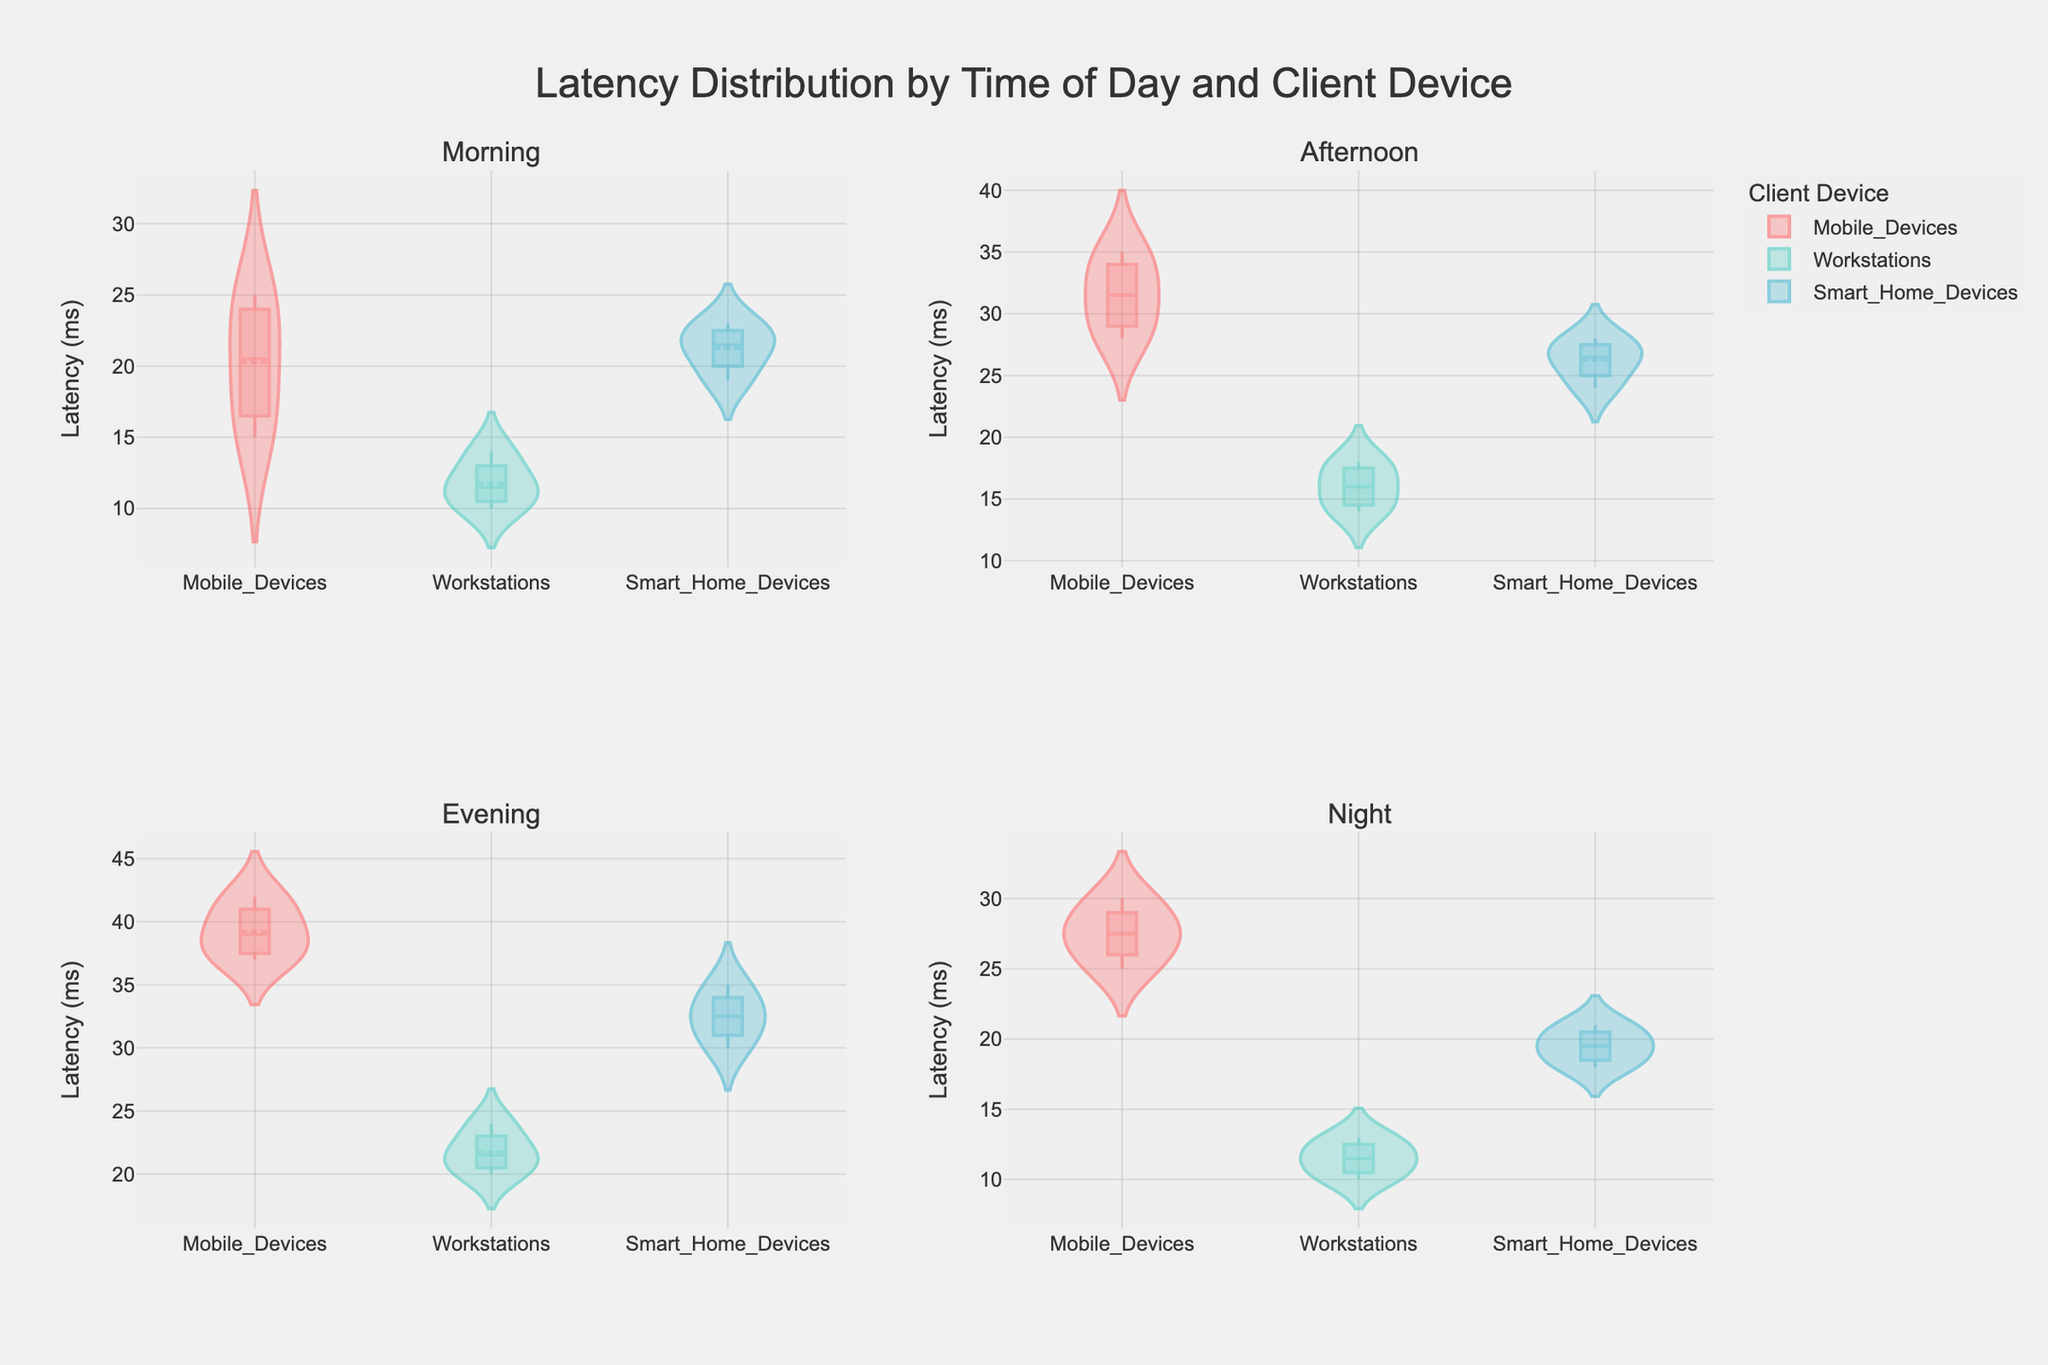Which time of day has the lowest latency for Mobile Devices? Look at the violin plots for Mobile Devices across all times of day. Identify the one with lower latency values. The Morning plot for Mobile Devices has the lowest latency.
Answer: Morning How does the median latency for Workstations in the Evening compare to that in the Night? Compare the center line of the violin plots for Workstations in the Evening and Night. The median latency for Workstations is around 21-22ms in the Evening and around 11-12ms at Night.
Answer: Night What is the spread of latency for Smart Home Devices in the Afternoon? Observing the height and distribution of data points for the Smart Home Devices in the Afternoon can reveal the spread. The latency ranges from approximately 24ms to 28ms.
Answer: 24-28ms Which client device shows the highest latency in the Evening? Look at the topmost part of the violin plots for the Evening. The maximum value for Mobile Devices appears highest around 42ms.
Answer: Mobile Devices During which time of the day do Workstations show the least variance in latency? To determine variance, observe the length and shape of the violin plots. Workstations display the shortest and most compact violin plot in the Morning, indicating the least variance.
Answer: Morning What's the average latency for Smart Home Devices in the Morning? To find the average, calculate the mean of the given latencies for Smart Home Devices in the Morning: (22 + 19 + 21 + 23)/4 = 21.25ms
Answer: 21.25ms How do the upper quartiles of latency for Mobile Devices compare between the Afternoon and evening? Examine the point where the violin plot narrows towards the top between Afternoon and Evening for Mobile Devices. The Afternoon's upper quartile appears around 35ms, while the Evening's upper quartile appears around 42ms.
Answer: Evening is higher Which client device has the most consistent latency across different times of day? Identify the violin plot with the least variation for each time period. Workstations appear most consistent as their plots are the most compact across all times.
Answer: Workstations Which client device shows the highest maximum latency in the Night? Look at the topmost part of the violin plots for the Night. Mobile Devices max out at around 30ms, which seems the highest among Night plots.
Answer: Mobile Devices 